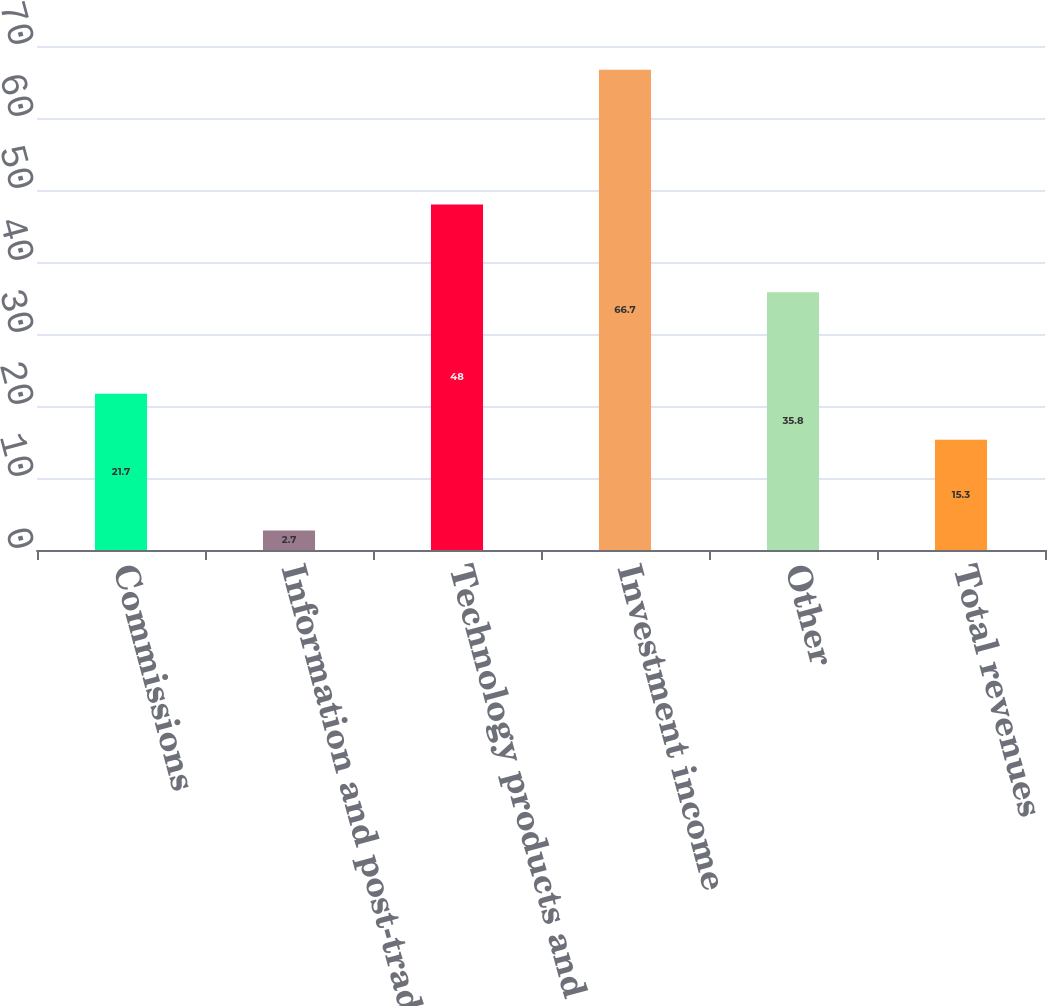Convert chart. <chart><loc_0><loc_0><loc_500><loc_500><bar_chart><fcel>Commissions<fcel>Information and post-trade<fcel>Technology products and<fcel>Investment income<fcel>Other<fcel>Total revenues<nl><fcel>21.7<fcel>2.7<fcel>48<fcel>66.7<fcel>35.8<fcel>15.3<nl></chart> 